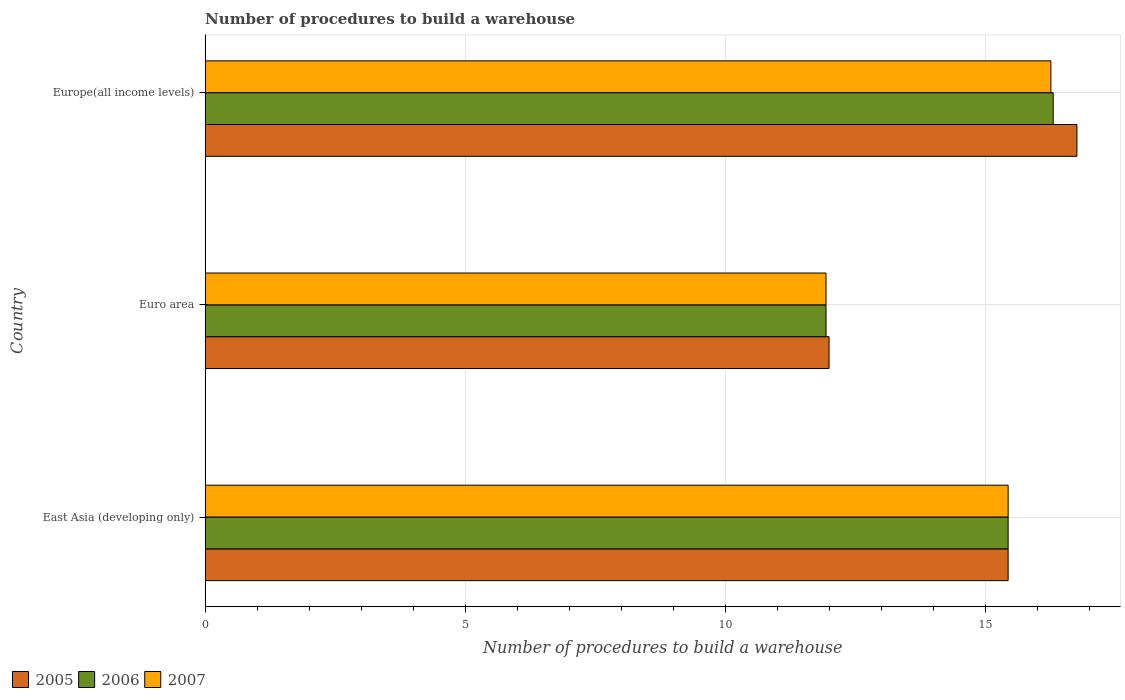How many different coloured bars are there?
Your answer should be very brief. 3. How many groups of bars are there?
Your answer should be compact. 3. Are the number of bars per tick equal to the number of legend labels?
Your response must be concise. Yes. Are the number of bars on each tick of the Y-axis equal?
Ensure brevity in your answer.  Yes. How many bars are there on the 1st tick from the bottom?
Ensure brevity in your answer.  3. What is the label of the 3rd group of bars from the top?
Your response must be concise. East Asia (developing only). What is the number of procedures to build a warehouse in in 2006 in East Asia (developing only)?
Provide a succinct answer. 15.44. Across all countries, what is the maximum number of procedures to build a warehouse in in 2007?
Give a very brief answer. 16.27. Across all countries, what is the minimum number of procedures to build a warehouse in in 2006?
Make the answer very short. 11.94. In which country was the number of procedures to build a warehouse in in 2006 maximum?
Offer a terse response. Europe(all income levels). In which country was the number of procedures to build a warehouse in in 2007 minimum?
Make the answer very short. Euro area. What is the total number of procedures to build a warehouse in in 2005 in the graph?
Provide a succinct answer. 44.21. What is the difference between the number of procedures to build a warehouse in in 2007 in Euro area and that in Europe(all income levels)?
Make the answer very short. -4.33. What is the difference between the number of procedures to build a warehouse in in 2007 in Euro area and the number of procedures to build a warehouse in in 2005 in Europe(all income levels)?
Your answer should be compact. -4.83. What is the average number of procedures to build a warehouse in in 2006 per country?
Offer a terse response. 14.57. What is the difference between the number of procedures to build a warehouse in in 2005 and number of procedures to build a warehouse in in 2007 in Euro area?
Offer a terse response. 0.06. What is the ratio of the number of procedures to build a warehouse in in 2007 in Euro area to that in Europe(all income levels)?
Offer a terse response. 0.73. Is the number of procedures to build a warehouse in in 2005 in East Asia (developing only) less than that in Europe(all income levels)?
Your answer should be very brief. Yes. What is the difference between the highest and the second highest number of procedures to build a warehouse in in 2007?
Give a very brief answer. 0.82. What is the difference between the highest and the lowest number of procedures to build a warehouse in in 2007?
Your answer should be compact. 4.33. What does the 3rd bar from the top in Euro area represents?
Provide a short and direct response. 2005. What does the 3rd bar from the bottom in Europe(all income levels) represents?
Give a very brief answer. 2007. How many bars are there?
Offer a very short reply. 9. Are all the bars in the graph horizontal?
Ensure brevity in your answer.  Yes. Does the graph contain grids?
Give a very brief answer. Yes. Where does the legend appear in the graph?
Keep it short and to the point. Bottom left. What is the title of the graph?
Keep it short and to the point. Number of procedures to build a warehouse. Does "2001" appear as one of the legend labels in the graph?
Offer a very short reply. No. What is the label or title of the X-axis?
Ensure brevity in your answer.  Number of procedures to build a warehouse. What is the Number of procedures to build a warehouse of 2005 in East Asia (developing only)?
Give a very brief answer. 15.44. What is the Number of procedures to build a warehouse in 2006 in East Asia (developing only)?
Keep it short and to the point. 15.44. What is the Number of procedures to build a warehouse in 2007 in East Asia (developing only)?
Offer a very short reply. 15.44. What is the Number of procedures to build a warehouse of 2005 in Euro area?
Offer a terse response. 12. What is the Number of procedures to build a warehouse in 2006 in Euro area?
Provide a succinct answer. 11.94. What is the Number of procedures to build a warehouse in 2007 in Euro area?
Offer a very short reply. 11.94. What is the Number of procedures to build a warehouse in 2005 in Europe(all income levels)?
Provide a short and direct response. 16.77. What is the Number of procedures to build a warehouse of 2006 in Europe(all income levels)?
Keep it short and to the point. 16.31. What is the Number of procedures to build a warehouse of 2007 in Europe(all income levels)?
Your answer should be compact. 16.27. Across all countries, what is the maximum Number of procedures to build a warehouse of 2005?
Your response must be concise. 16.77. Across all countries, what is the maximum Number of procedures to build a warehouse in 2006?
Ensure brevity in your answer.  16.31. Across all countries, what is the maximum Number of procedures to build a warehouse of 2007?
Your answer should be compact. 16.27. Across all countries, what is the minimum Number of procedures to build a warehouse in 2006?
Your answer should be very brief. 11.94. Across all countries, what is the minimum Number of procedures to build a warehouse of 2007?
Offer a terse response. 11.94. What is the total Number of procedures to build a warehouse of 2005 in the graph?
Offer a very short reply. 44.21. What is the total Number of procedures to build a warehouse in 2006 in the graph?
Offer a very short reply. 43.7. What is the total Number of procedures to build a warehouse in 2007 in the graph?
Your answer should be very brief. 43.65. What is the difference between the Number of procedures to build a warehouse of 2005 in East Asia (developing only) and that in Euro area?
Ensure brevity in your answer.  3.44. What is the difference between the Number of procedures to build a warehouse in 2006 in East Asia (developing only) and that in Euro area?
Keep it short and to the point. 3.5. What is the difference between the Number of procedures to build a warehouse in 2007 in East Asia (developing only) and that in Euro area?
Your answer should be compact. 3.5. What is the difference between the Number of procedures to build a warehouse of 2005 in East Asia (developing only) and that in Europe(all income levels)?
Offer a very short reply. -1.32. What is the difference between the Number of procedures to build a warehouse of 2006 in East Asia (developing only) and that in Europe(all income levels)?
Keep it short and to the point. -0.87. What is the difference between the Number of procedures to build a warehouse in 2007 in East Asia (developing only) and that in Europe(all income levels)?
Keep it short and to the point. -0.82. What is the difference between the Number of procedures to build a warehouse in 2005 in Euro area and that in Europe(all income levels)?
Provide a short and direct response. -4.77. What is the difference between the Number of procedures to build a warehouse of 2006 in Euro area and that in Europe(all income levels)?
Provide a succinct answer. -4.37. What is the difference between the Number of procedures to build a warehouse of 2007 in Euro area and that in Europe(all income levels)?
Your answer should be very brief. -4.33. What is the difference between the Number of procedures to build a warehouse of 2005 in East Asia (developing only) and the Number of procedures to build a warehouse of 2006 in Euro area?
Make the answer very short. 3.5. What is the difference between the Number of procedures to build a warehouse of 2005 in East Asia (developing only) and the Number of procedures to build a warehouse of 2007 in Euro area?
Your response must be concise. 3.5. What is the difference between the Number of procedures to build a warehouse in 2006 in East Asia (developing only) and the Number of procedures to build a warehouse in 2007 in Euro area?
Provide a short and direct response. 3.5. What is the difference between the Number of procedures to build a warehouse of 2005 in East Asia (developing only) and the Number of procedures to build a warehouse of 2006 in Europe(all income levels)?
Make the answer very short. -0.87. What is the difference between the Number of procedures to build a warehouse in 2005 in East Asia (developing only) and the Number of procedures to build a warehouse in 2007 in Europe(all income levels)?
Give a very brief answer. -0.82. What is the difference between the Number of procedures to build a warehouse of 2006 in East Asia (developing only) and the Number of procedures to build a warehouse of 2007 in Europe(all income levels)?
Offer a terse response. -0.82. What is the difference between the Number of procedures to build a warehouse of 2005 in Euro area and the Number of procedures to build a warehouse of 2006 in Europe(all income levels)?
Your answer should be very brief. -4.31. What is the difference between the Number of procedures to build a warehouse in 2005 in Euro area and the Number of procedures to build a warehouse in 2007 in Europe(all income levels)?
Give a very brief answer. -4.27. What is the difference between the Number of procedures to build a warehouse of 2006 in Euro area and the Number of procedures to build a warehouse of 2007 in Europe(all income levels)?
Offer a very short reply. -4.33. What is the average Number of procedures to build a warehouse of 2005 per country?
Give a very brief answer. 14.74. What is the average Number of procedures to build a warehouse of 2006 per country?
Offer a very short reply. 14.57. What is the average Number of procedures to build a warehouse in 2007 per country?
Offer a terse response. 14.55. What is the difference between the Number of procedures to build a warehouse of 2005 and Number of procedures to build a warehouse of 2006 in Euro area?
Your response must be concise. 0.06. What is the difference between the Number of procedures to build a warehouse of 2005 and Number of procedures to build a warehouse of 2007 in Euro area?
Offer a very short reply. 0.06. What is the difference between the Number of procedures to build a warehouse in 2006 and Number of procedures to build a warehouse in 2007 in Euro area?
Give a very brief answer. 0. What is the difference between the Number of procedures to build a warehouse of 2005 and Number of procedures to build a warehouse of 2006 in Europe(all income levels)?
Make the answer very short. 0.46. What is the difference between the Number of procedures to build a warehouse of 2005 and Number of procedures to build a warehouse of 2007 in Europe(all income levels)?
Your answer should be compact. 0.5. What is the difference between the Number of procedures to build a warehouse of 2006 and Number of procedures to build a warehouse of 2007 in Europe(all income levels)?
Provide a succinct answer. 0.04. What is the ratio of the Number of procedures to build a warehouse in 2005 in East Asia (developing only) to that in Euro area?
Your answer should be very brief. 1.29. What is the ratio of the Number of procedures to build a warehouse in 2006 in East Asia (developing only) to that in Euro area?
Offer a terse response. 1.29. What is the ratio of the Number of procedures to build a warehouse of 2007 in East Asia (developing only) to that in Euro area?
Keep it short and to the point. 1.29. What is the ratio of the Number of procedures to build a warehouse of 2005 in East Asia (developing only) to that in Europe(all income levels)?
Give a very brief answer. 0.92. What is the ratio of the Number of procedures to build a warehouse of 2006 in East Asia (developing only) to that in Europe(all income levels)?
Make the answer very short. 0.95. What is the ratio of the Number of procedures to build a warehouse in 2007 in East Asia (developing only) to that in Europe(all income levels)?
Give a very brief answer. 0.95. What is the ratio of the Number of procedures to build a warehouse of 2005 in Euro area to that in Europe(all income levels)?
Ensure brevity in your answer.  0.72. What is the ratio of the Number of procedures to build a warehouse in 2006 in Euro area to that in Europe(all income levels)?
Keep it short and to the point. 0.73. What is the ratio of the Number of procedures to build a warehouse of 2007 in Euro area to that in Europe(all income levels)?
Your answer should be very brief. 0.73. What is the difference between the highest and the second highest Number of procedures to build a warehouse in 2005?
Your answer should be very brief. 1.32. What is the difference between the highest and the second highest Number of procedures to build a warehouse of 2006?
Provide a short and direct response. 0.87. What is the difference between the highest and the second highest Number of procedures to build a warehouse in 2007?
Your answer should be very brief. 0.82. What is the difference between the highest and the lowest Number of procedures to build a warehouse in 2005?
Your response must be concise. 4.77. What is the difference between the highest and the lowest Number of procedures to build a warehouse in 2006?
Ensure brevity in your answer.  4.37. What is the difference between the highest and the lowest Number of procedures to build a warehouse of 2007?
Provide a short and direct response. 4.33. 